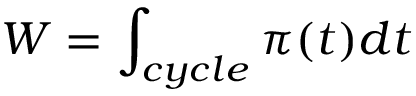<formula> <loc_0><loc_0><loc_500><loc_500>W = \int _ { c y c l e } { \pi ( t ) d t }</formula> 